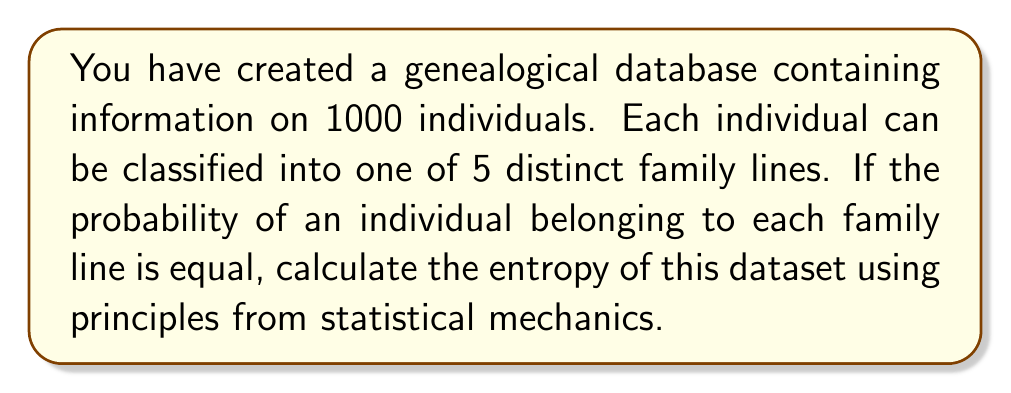Give your solution to this math problem. To solve this problem, we'll use the concept of entropy from statistical mechanics and apply it to our genealogical dataset. Here's a step-by-step approach:

1) In statistical mechanics, the entropy S is given by Boltzmann's formula:

   $$S = k_B \ln W$$

   Where $k_B$ is Boltzmann's constant and W is the number of microstates.

2) In information theory, which is closely related to statistical mechanics, we use the Shannon entropy formula:

   $$S = -\sum_{i=1}^n p_i \ln p_i$$

   Where $p_i$ is the probability of the i-th state.

3) In our case, we have 5 equally probable family lines, so:

   $$p_1 = p_2 = p_3 = p_4 = p_5 = \frac{1}{5}$$

4) Plugging this into the Shannon entropy formula:

   $$S = -5 \cdot \frac{1}{5} \ln \frac{1}{5}$$

5) Simplifying:

   $$S = -\ln \frac{1}{5} = \ln 5$$

6) Therefore, the entropy of our genealogical dataset is $\ln 5$ nats.

   Note: The unit 'nats' is used when the natural logarithm is employed. If we were to use log base 2, the unit would be 'bits'.
Answer: $\ln 5$ nats 